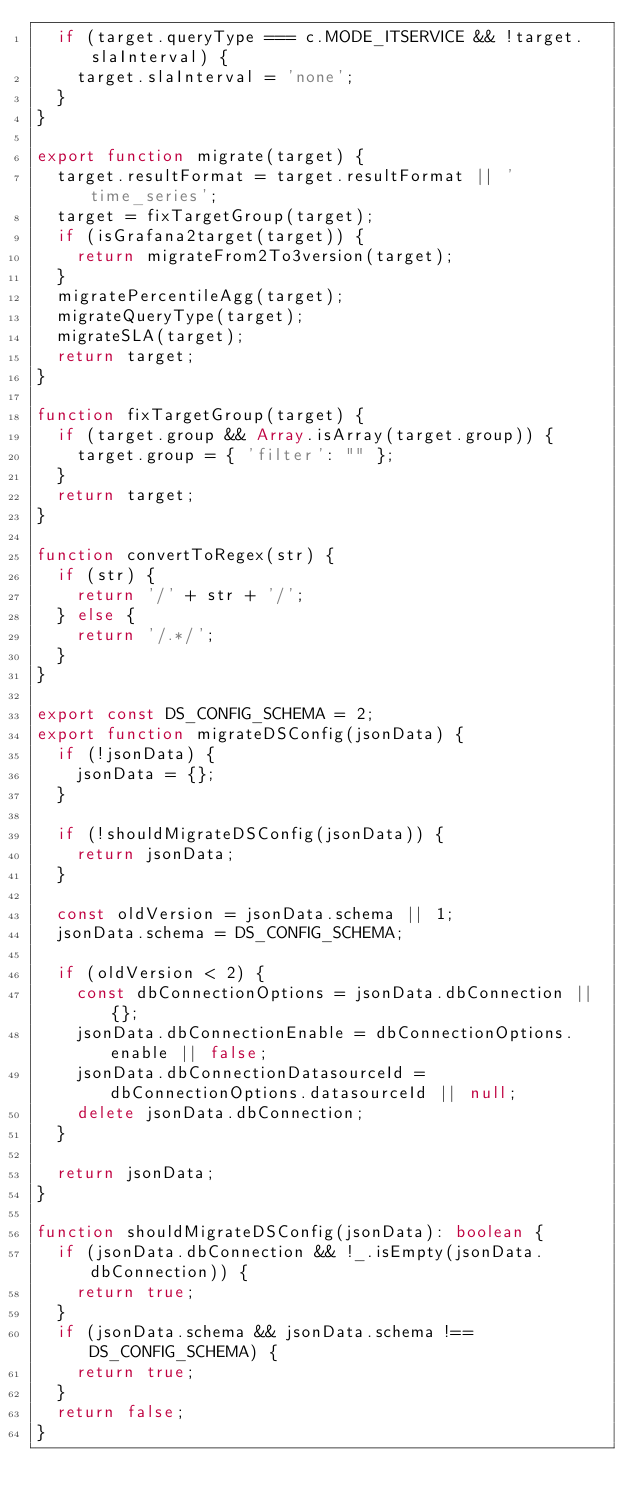<code> <loc_0><loc_0><loc_500><loc_500><_TypeScript_>  if (target.queryType === c.MODE_ITSERVICE && !target.slaInterval) {
    target.slaInterval = 'none';
  }
}

export function migrate(target) {
  target.resultFormat = target.resultFormat || 'time_series';
  target = fixTargetGroup(target);
  if (isGrafana2target(target)) {
    return migrateFrom2To3version(target);
  }
  migratePercentileAgg(target);
  migrateQueryType(target);
  migrateSLA(target);
  return target;
}

function fixTargetGroup(target) {
  if (target.group && Array.isArray(target.group)) {
    target.group = { 'filter': "" };
  }
  return target;
}

function convertToRegex(str) {
  if (str) {
    return '/' + str + '/';
  } else {
    return '/.*/';
  }
}

export const DS_CONFIG_SCHEMA = 2;
export function migrateDSConfig(jsonData) {
  if (!jsonData) {
    jsonData = {};
  }

  if (!shouldMigrateDSConfig(jsonData)) {
    return jsonData;
  }

  const oldVersion = jsonData.schema || 1;
  jsonData.schema = DS_CONFIG_SCHEMA;

  if (oldVersion < 2) {
    const dbConnectionOptions = jsonData.dbConnection || {};
    jsonData.dbConnectionEnable = dbConnectionOptions.enable || false;
    jsonData.dbConnectionDatasourceId = dbConnectionOptions.datasourceId || null;
    delete jsonData.dbConnection;
  }

  return jsonData;
}

function shouldMigrateDSConfig(jsonData): boolean {
  if (jsonData.dbConnection && !_.isEmpty(jsonData.dbConnection)) {
    return true;
  }
  if (jsonData.schema && jsonData.schema !== DS_CONFIG_SCHEMA) {
    return true;
  }
  return false;
}
</code> 